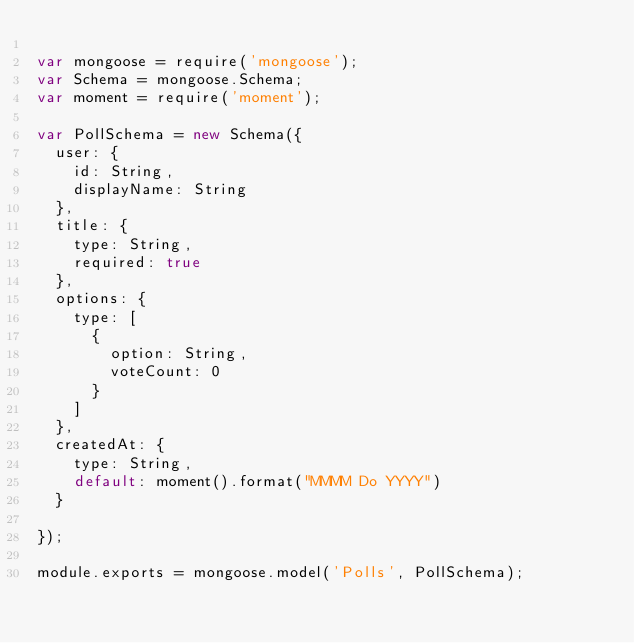<code> <loc_0><loc_0><loc_500><loc_500><_JavaScript_>
var mongoose = require('mongoose');
var Schema = mongoose.Schema;
var moment = require('moment');

var PollSchema = new Schema({
  user: {
    id: String,
    displayName: String
  },
  title: {
    type: String,
    required: true
  },
  options: {
    type: [
      {
        option: String,
        voteCount: 0
      }
    ]
  },
  createdAt: {
    type: String,
    default: moment().format("MMMM Do YYYY")
  }

});

module.exports = mongoose.model('Polls', PollSchema);


</code> 